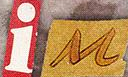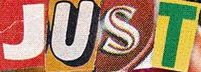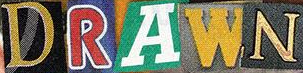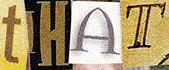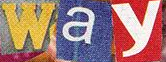Transcribe the words shown in these images in order, separated by a semicolon. iM; JUST; DRAWN; tHAT; way 